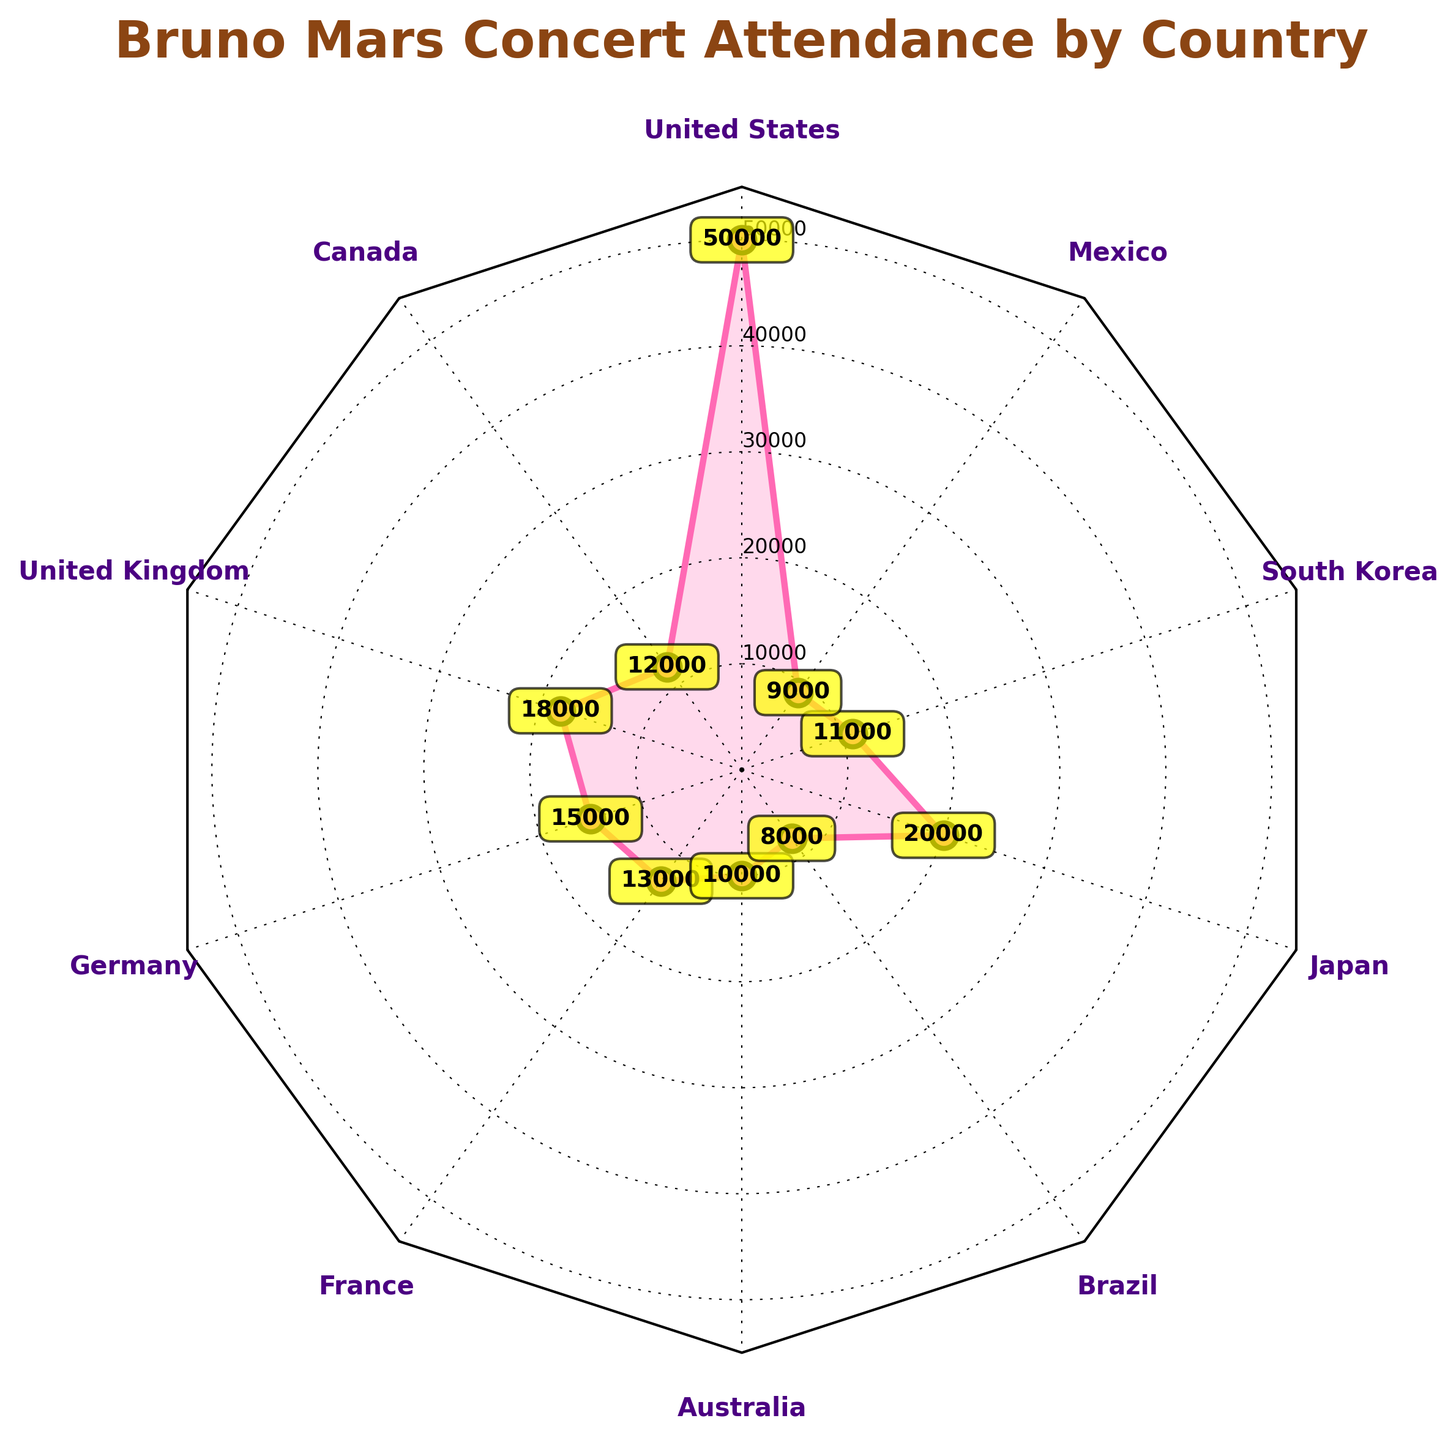What is the minimum concert attendance for Bruno Mars? The minimum concert attendance can be found by identifying the smallest value on the radar chart. Looking at each country's attendance, the lowest value is 8,000 in Brazil.
Answer: 8,000 Which country has the highest concert attendance for Bruno Mars? The highest concert attendance can be observed by finding the largest value plotted on the radar chart. The United States has the highest attendance with 50,000.
Answer: United States What is the range of concert attendance values? The range can be calculated by subtracting the minimum attendance value from the maximum attendance value. The maximum is 50,000 (United States) and the minimum is 8,000 (Brazil), giving us a range of 50,000 - 8,000.
Answer: 42,000 How many countries have a concert attendance of more than 15,000? To find the number of countries with attendance more than 15,000, list the countries and check their attendance values. The relevant countries are the United States (50,000), the United Kingdom (18,000), Germany (15,000), France (13,000), and Japan (20,000).
Answer: 3 What is the combined concert attendance for Canada and Australia? The combined attendance is found by adding the attendance for Canada (12,000) and Australia (10,000). So, 12,000 + 10,000 = 22,000.
Answer: 22,000 Which two countries have the closest concert attendance numbers? To find the closest numbers, calculate the difference between attendances for each pair of countries and identify the smallest difference. The closest attendance numbers are Canada (12,000) and South Korea (11,000) with a difference of 1,000.
Answer: Canada and South Korea What is the average concert attendance across all the countries? To find the average, sum all the attendance numbers and divide by the number of countries. The sum is 50,000 + 12,000 + 18,000 + 15,000 + 13,000 + 10,000 + 8,000 + 20,000 + 11,000 + 9,000 = 166,000; dividing by 10 gives the average as 166,000 / 10 = 16,600.
Answer: 16,600 Rank Brazil, Mexico, and France by their concert attendance. To rank these countries, arrange their attendance values in ascending order. The values are: Brazil (8,000), Mexico (9,000), and France (13,000). The rank is: Brazil, Mexico, then France.
Answer: Brazil < Mexico < France What are the concert attendance values in South Korea and Japan, and how do they compare? South Korea has an attendance of 11,000, and Japan has 20,000. Comparing these, Japan has a higher attendance by 9,000.
Answer: Japan has a higher attendance by 9,000 What is the total concert attendance for all countries combined? Total concert attendance can be found by summing up the attendance values for all countries. The sum is 50,000 + 12,000 + 18,000 + 15,000 + 13,000 + 10,000 + 8,000 + 20,000 + 11,000 + 9,000 = 166,000.
Answer: 166,000 